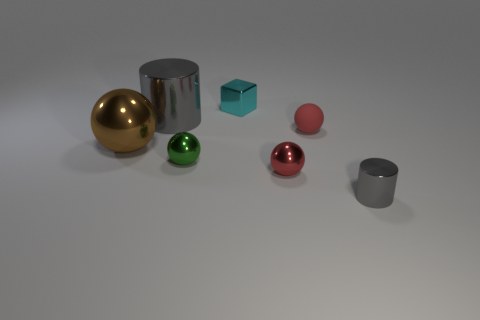There is a tiny metallic object that is behind the small rubber thing; is there a gray metal thing that is to the left of it? Yes, there is a gray metallic cylinder to the left of the small turquoise cube, which is made of rubber. The arrangement of objects on the surface includes various shapes and materials, positioned in a way that creates a visually balanced scene. 